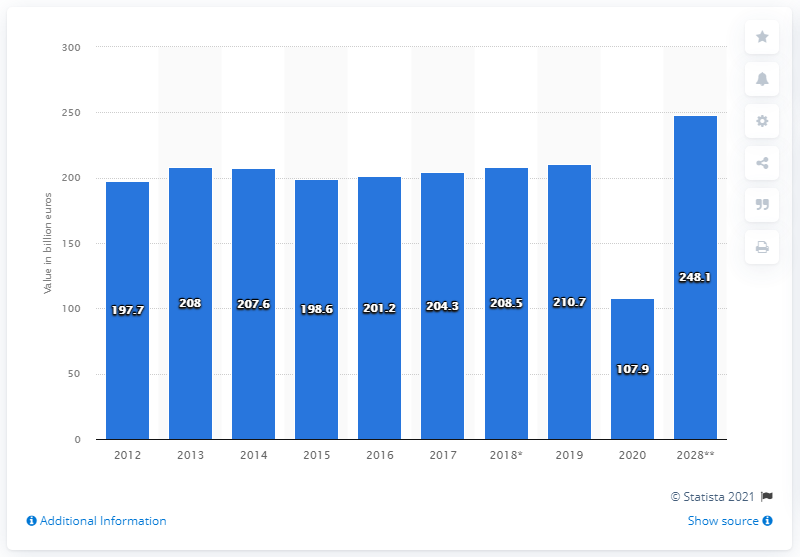Indicate a few pertinent items in this graphic. In 2020, the travel and tourism industry contributed 107.9% to France's Gross Domestic Product (GDP). In 2019, the travel and tourism industry contributed 210.7% to France's Gross Domestic Product (GDP). According to projections, the travel and tourism sector is expected to make a significant contribution to France's Gross Domestic Product (GDP) in 2028, with an estimated value of 248.1. 